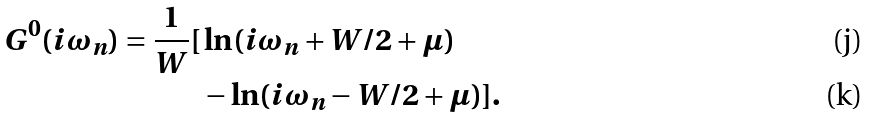Convert formula to latex. <formula><loc_0><loc_0><loc_500><loc_500>G ^ { 0 } ( i \omega _ { n } ) = \frac { 1 } { W } [ & \ln ( i \omega _ { n } + W / 2 + \mu ) \\ & - \ln ( i \omega _ { n } - W / 2 + \mu ) ] .</formula> 